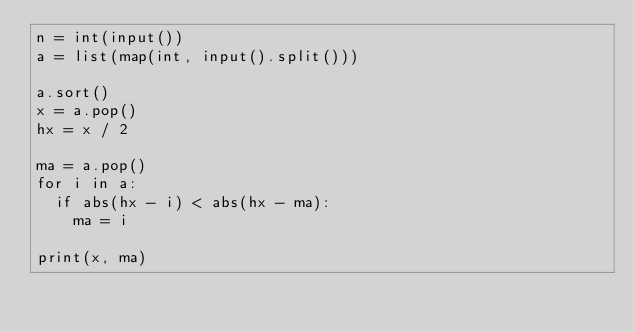Convert code to text. <code><loc_0><loc_0><loc_500><loc_500><_Python_>n = int(input())
a = list(map(int, input().split()))

a.sort()
x = a.pop()
hx = x / 2

ma = a.pop()
for i in a:
  if abs(hx - i) < abs(hx - ma):
    ma = i
    
print(x, ma)</code> 